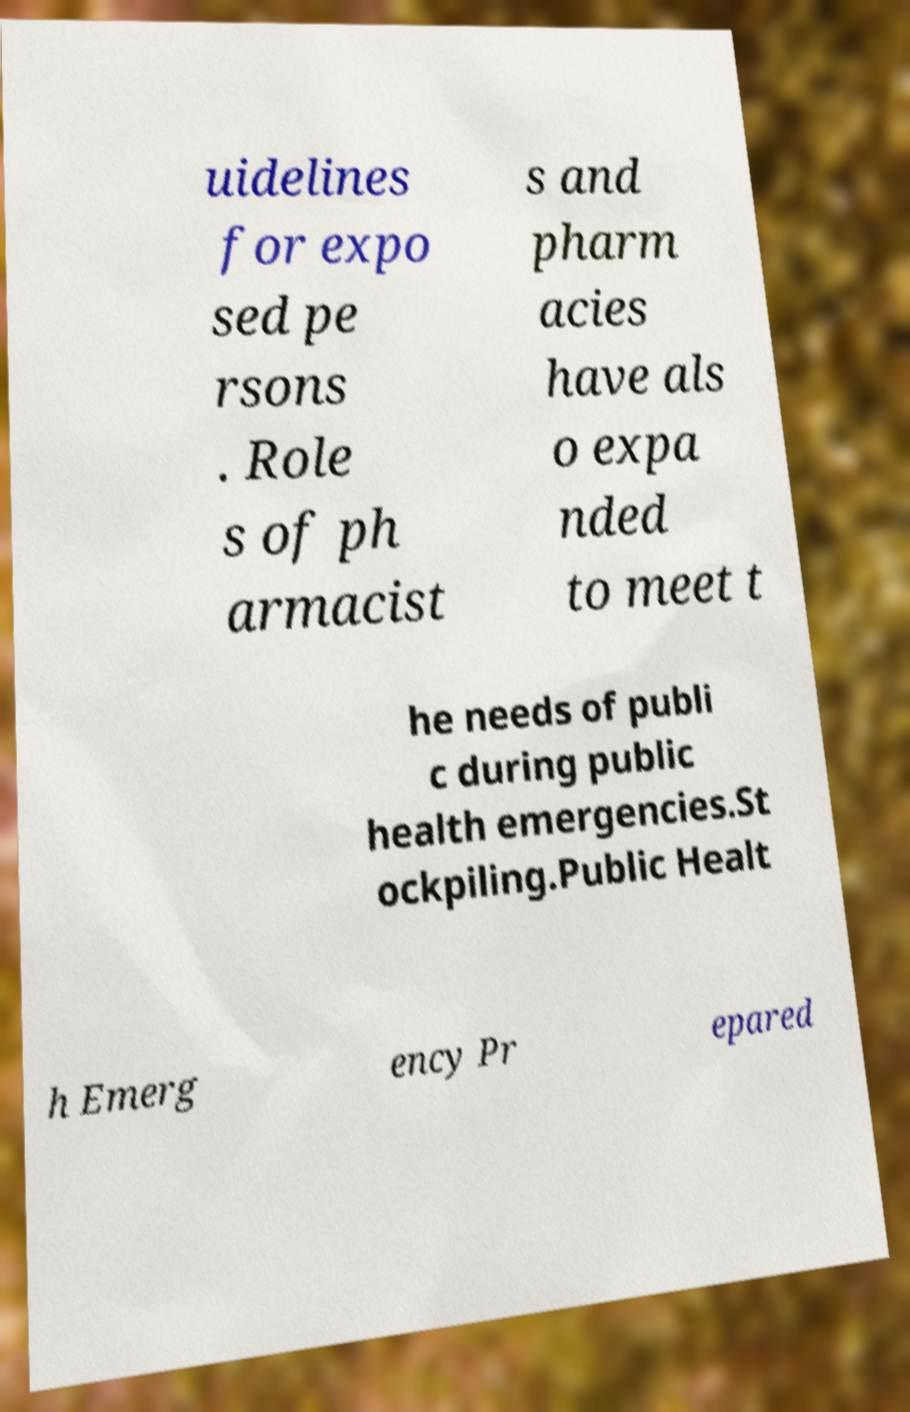I need the written content from this picture converted into text. Can you do that? uidelines for expo sed pe rsons . Role s of ph armacist s and pharm acies have als o expa nded to meet t he needs of publi c during public health emergencies.St ockpiling.Public Healt h Emerg ency Pr epared 